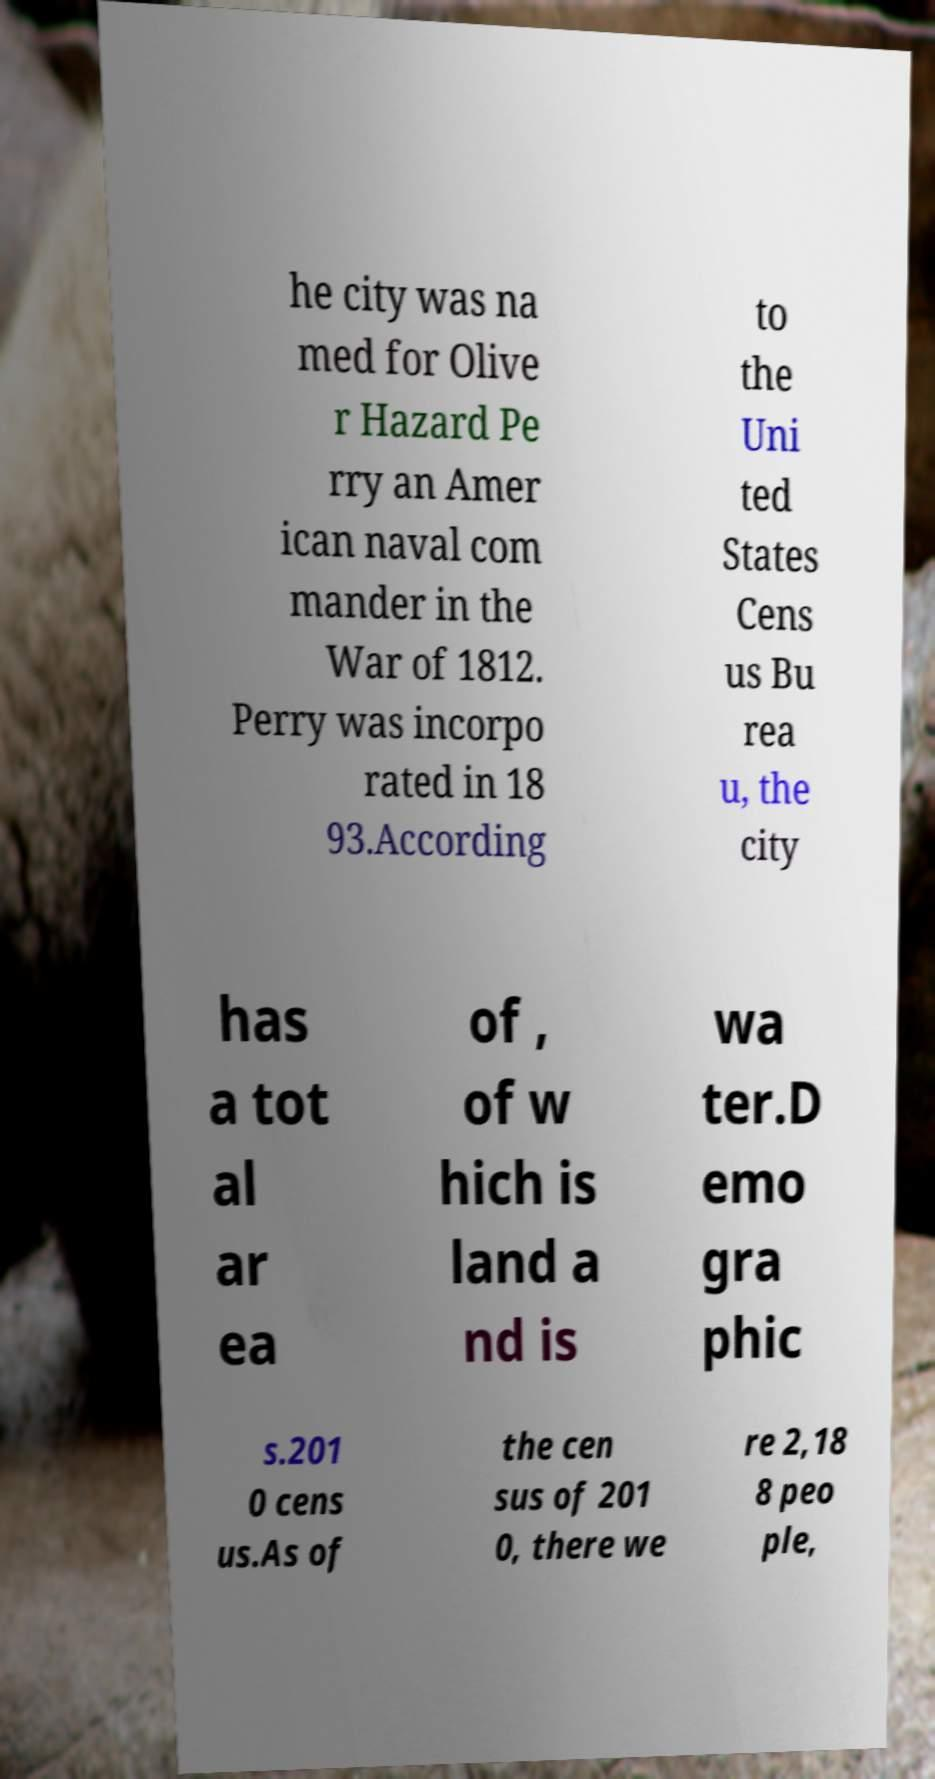I need the written content from this picture converted into text. Can you do that? he city was na med for Olive r Hazard Pe rry an Amer ican naval com mander in the War of 1812. Perry was incorpo rated in 18 93.According to the Uni ted States Cens us Bu rea u, the city has a tot al ar ea of , of w hich is land a nd is wa ter.D emo gra phic s.201 0 cens us.As of the cen sus of 201 0, there we re 2,18 8 peo ple, 